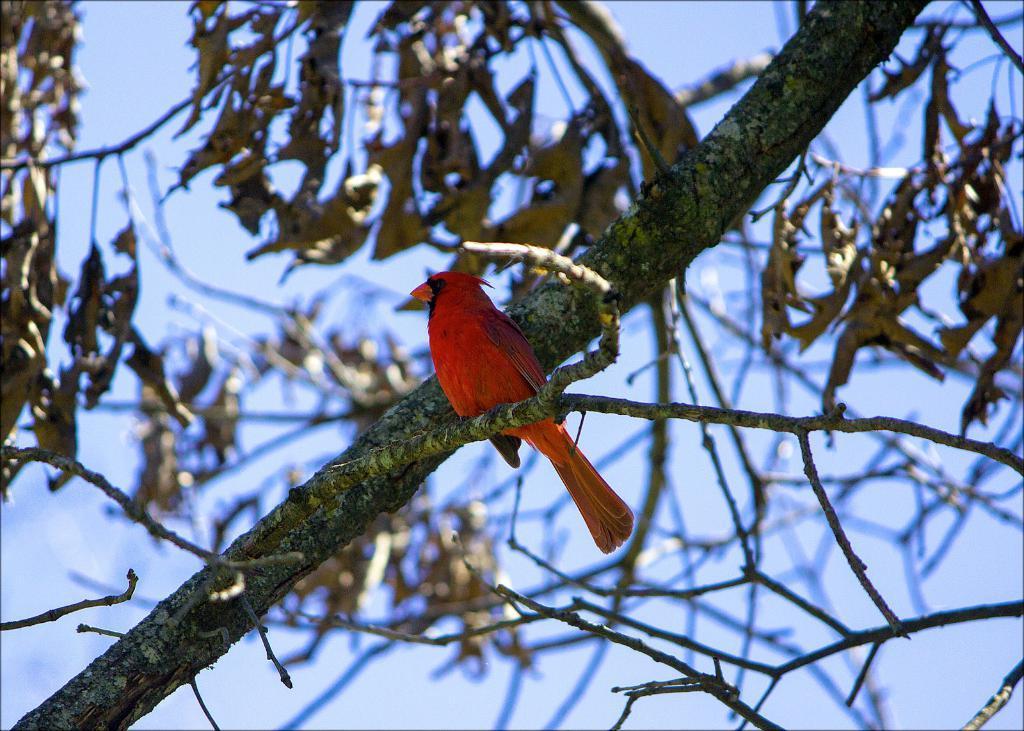Can you describe this image briefly? In this image, we can see a red bird on the tree stem. Here we can see tree leaves. Background there is a blur view. Here there is a sky. 